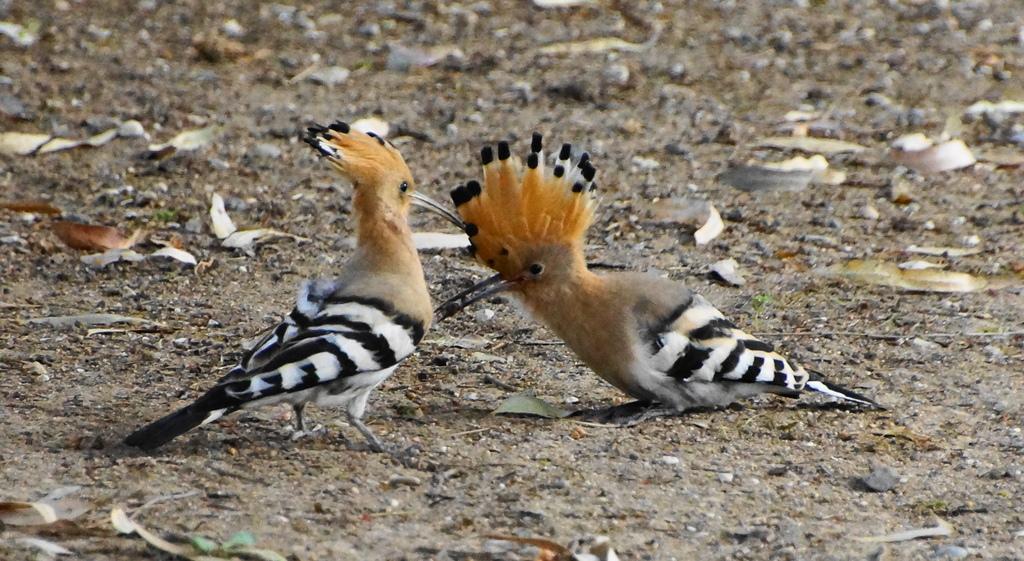How would you summarize this image in a sentence or two? In this image there are two birds standing on the ground and poking each other with their beaks. On the ground there are stones and dry leaves. 